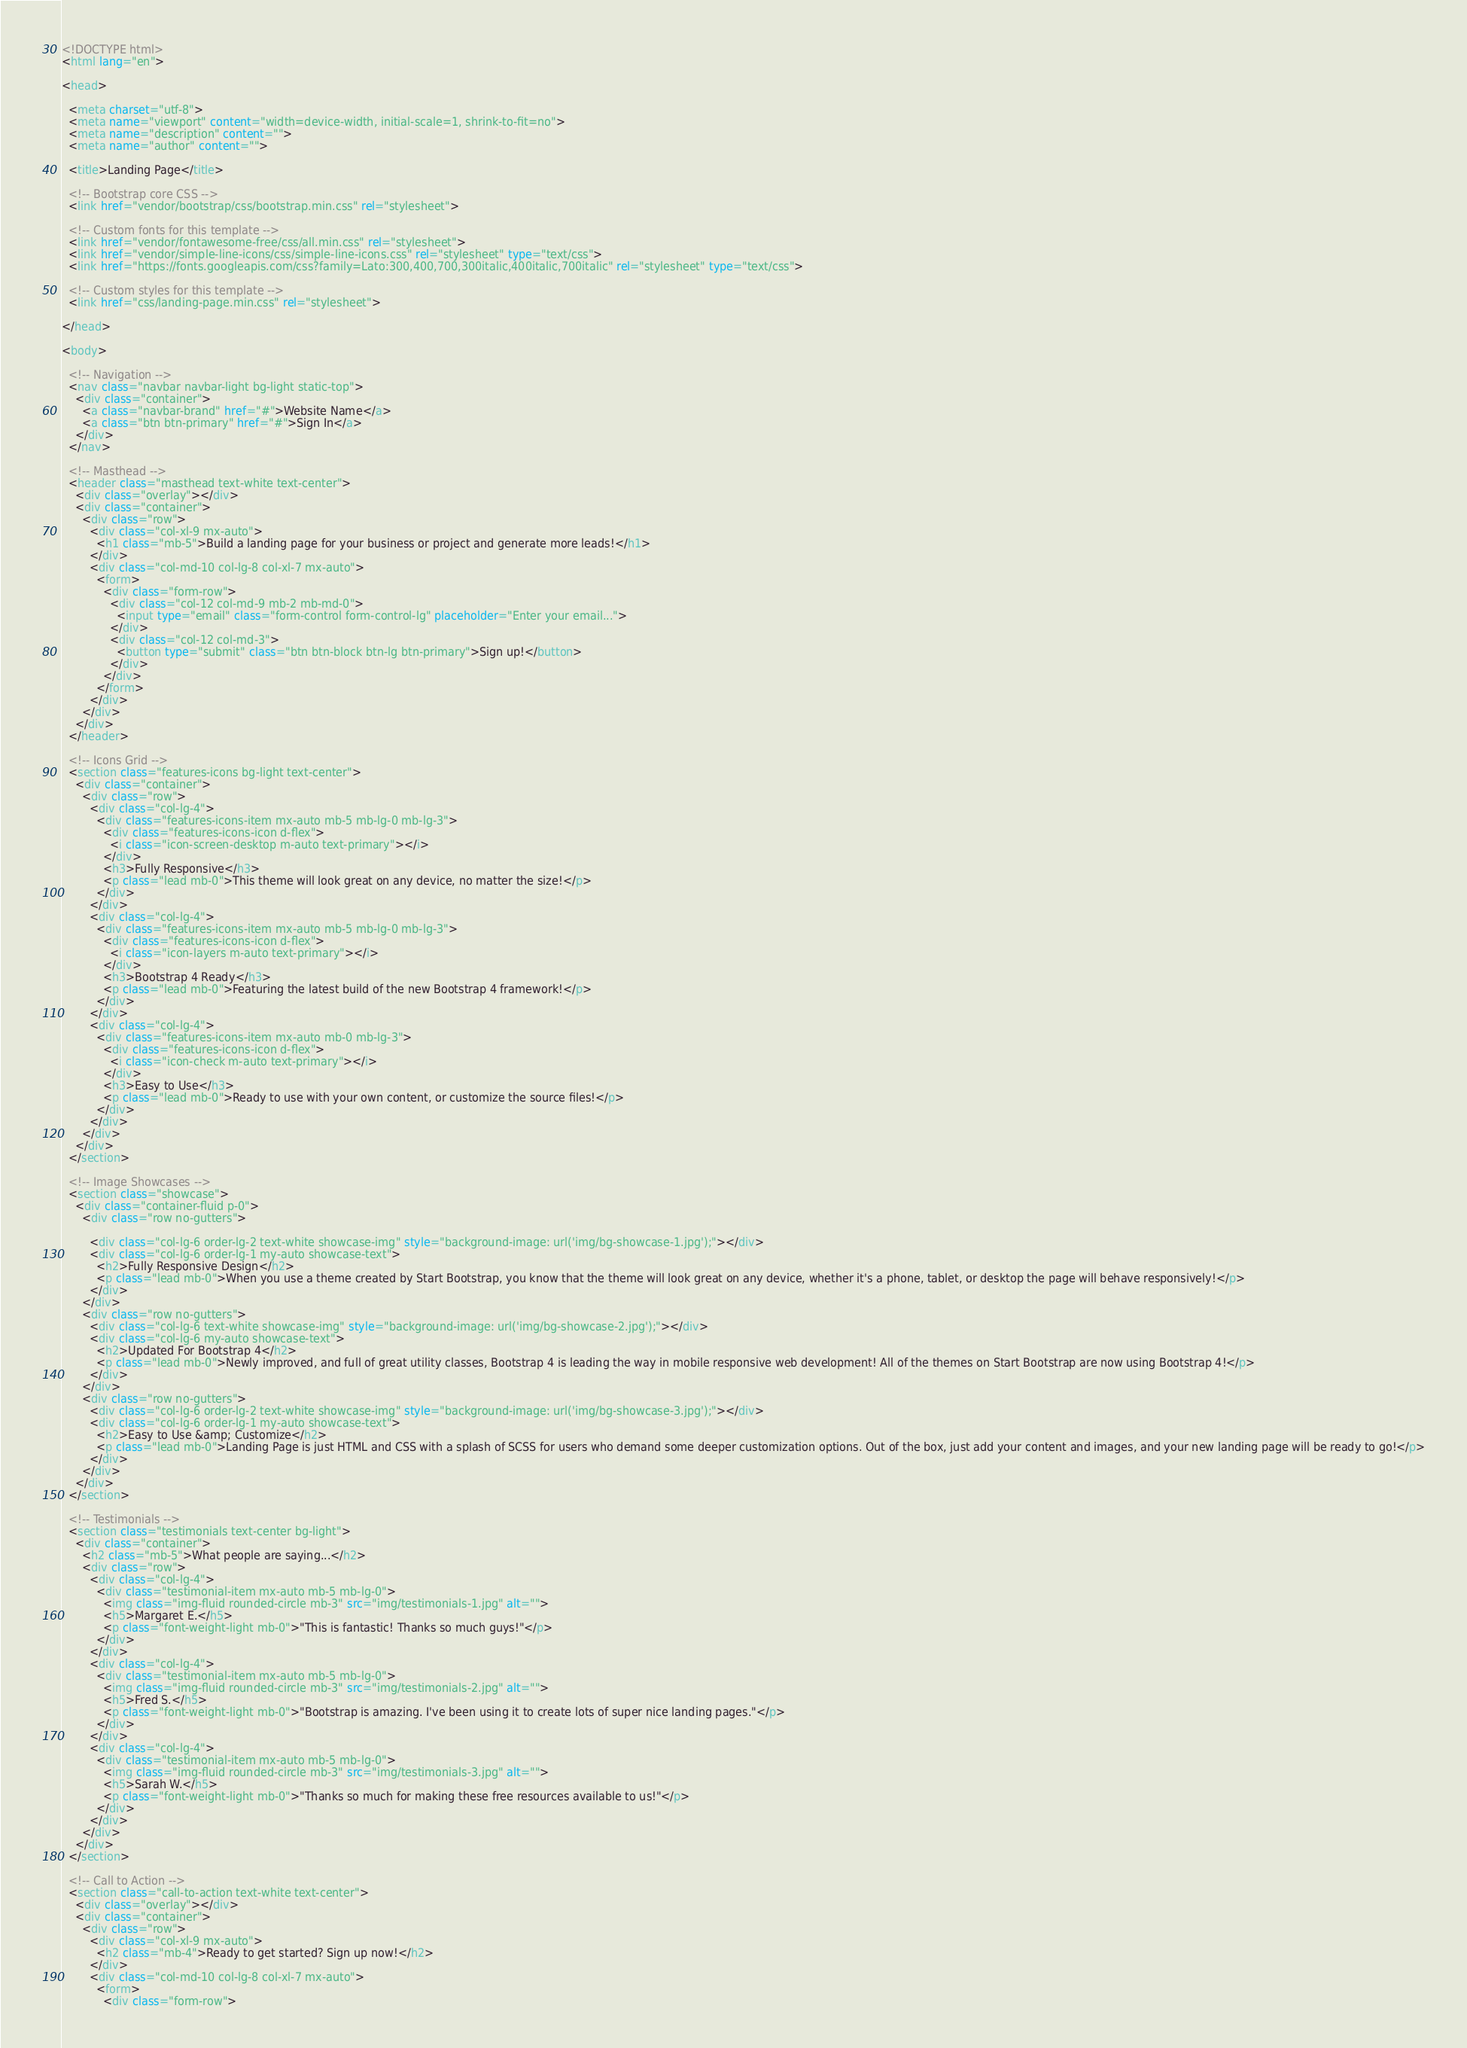<code> <loc_0><loc_0><loc_500><loc_500><_HTML_><!DOCTYPE html>
<html lang="en">

<head>

  <meta charset="utf-8">
  <meta name="viewport" content="width=device-width, initial-scale=1, shrink-to-fit=no">
  <meta name="description" content="">
  <meta name="author" content="">

  <title>Landing Page</title>

  <!-- Bootstrap core CSS -->
  <link href="vendor/bootstrap/css/bootstrap.min.css" rel="stylesheet">

  <!-- Custom fonts for this template -->
  <link href="vendor/fontawesome-free/css/all.min.css" rel="stylesheet">
  <link href="vendor/simple-line-icons/css/simple-line-icons.css" rel="stylesheet" type="text/css">
  <link href="https://fonts.googleapis.com/css?family=Lato:300,400,700,300italic,400italic,700italic" rel="stylesheet" type="text/css">

  <!-- Custom styles for this template -->
  <link href="css/landing-page.min.css" rel="stylesheet">

</head>

<body>

  <!-- Navigation -->
  <nav class="navbar navbar-light bg-light static-top">
    <div class="container">
      <a class="navbar-brand" href="#">Website Name</a>
      <a class="btn btn-primary" href="#">Sign In</a>
    </div>
  </nav>

  <!-- Masthead -->
  <header class="masthead text-white text-center">
    <div class="overlay"></div>
    <div class="container">
      <div class="row">
        <div class="col-xl-9 mx-auto">
          <h1 class="mb-5">Build a landing page for your business or project and generate more leads!</h1>
        </div>
        <div class="col-md-10 col-lg-8 col-xl-7 mx-auto">
          <form>
            <div class="form-row">
              <div class="col-12 col-md-9 mb-2 mb-md-0">
                <input type="email" class="form-control form-control-lg" placeholder="Enter your email...">
              </div>
              <div class="col-12 col-md-3">
                <button type="submit" class="btn btn-block btn-lg btn-primary">Sign up!</button>
              </div>
            </div>
          </form>
        </div>
      </div>
    </div>
  </header>

  <!-- Icons Grid -->
  <section class="features-icons bg-light text-center">
    <div class="container">
      <div class="row">
        <div class="col-lg-4">
          <div class="features-icons-item mx-auto mb-5 mb-lg-0 mb-lg-3">
            <div class="features-icons-icon d-flex">
              <i class="icon-screen-desktop m-auto text-primary"></i>
            </div>
            <h3>Fully Responsive</h3>
            <p class="lead mb-0">This theme will look great on any device, no matter the size!</p>
          </div>
        </div>
        <div class="col-lg-4">
          <div class="features-icons-item mx-auto mb-5 mb-lg-0 mb-lg-3">
            <div class="features-icons-icon d-flex">
              <i class="icon-layers m-auto text-primary"></i>
            </div>
            <h3>Bootstrap 4 Ready</h3>
            <p class="lead mb-0">Featuring the latest build of the new Bootstrap 4 framework!</p>
          </div>
        </div>
        <div class="col-lg-4">
          <div class="features-icons-item mx-auto mb-0 mb-lg-3">
            <div class="features-icons-icon d-flex">
              <i class="icon-check m-auto text-primary"></i>
            </div>
            <h3>Easy to Use</h3>
            <p class="lead mb-0">Ready to use with your own content, or customize the source files!</p>
          </div>
        </div>
      </div>
    </div>
  </section>

  <!-- Image Showcases -->
  <section class="showcase">
    <div class="container-fluid p-0">
      <div class="row no-gutters">

        <div class="col-lg-6 order-lg-2 text-white showcase-img" style="background-image: url('img/bg-showcase-1.jpg');"></div>
        <div class="col-lg-6 order-lg-1 my-auto showcase-text">
          <h2>Fully Responsive Design</h2>
          <p class="lead mb-0">When you use a theme created by Start Bootstrap, you know that the theme will look great on any device, whether it's a phone, tablet, or desktop the page will behave responsively!</p>
        </div>
      </div>
      <div class="row no-gutters">
        <div class="col-lg-6 text-white showcase-img" style="background-image: url('img/bg-showcase-2.jpg');"></div>
        <div class="col-lg-6 my-auto showcase-text">
          <h2>Updated For Bootstrap 4</h2>
          <p class="lead mb-0">Newly improved, and full of great utility classes, Bootstrap 4 is leading the way in mobile responsive web development! All of the themes on Start Bootstrap are now using Bootstrap 4!</p>
        </div>
      </div>
      <div class="row no-gutters">
        <div class="col-lg-6 order-lg-2 text-white showcase-img" style="background-image: url('img/bg-showcase-3.jpg');"></div>
        <div class="col-lg-6 order-lg-1 my-auto showcase-text">
          <h2>Easy to Use &amp; Customize</h2>
          <p class="lead mb-0">Landing Page is just HTML and CSS with a splash of SCSS for users who demand some deeper customization options. Out of the box, just add your content and images, and your new landing page will be ready to go!</p>
        </div>
      </div>
    </div>
  </section>

  <!-- Testimonials -->
  <section class="testimonials text-center bg-light">
    <div class="container">
      <h2 class="mb-5">What people are saying...</h2>
      <div class="row">
        <div class="col-lg-4">
          <div class="testimonial-item mx-auto mb-5 mb-lg-0">
            <img class="img-fluid rounded-circle mb-3" src="img/testimonials-1.jpg" alt="">
            <h5>Margaret E.</h5>
            <p class="font-weight-light mb-0">"This is fantastic! Thanks so much guys!"</p>
          </div>
        </div>
        <div class="col-lg-4">
          <div class="testimonial-item mx-auto mb-5 mb-lg-0">
            <img class="img-fluid rounded-circle mb-3" src="img/testimonials-2.jpg" alt="">
            <h5>Fred S.</h5>
            <p class="font-weight-light mb-0">"Bootstrap is amazing. I've been using it to create lots of super nice landing pages."</p>
          </div>
        </div>
        <div class="col-lg-4">
          <div class="testimonial-item mx-auto mb-5 mb-lg-0">
            <img class="img-fluid rounded-circle mb-3" src="img/testimonials-3.jpg" alt="">
            <h5>Sarah W.</h5>
            <p class="font-weight-light mb-0">"Thanks so much for making these free resources available to us!"</p>
          </div>
        </div>
      </div>
    </div>
  </section>

  <!-- Call to Action -->
  <section class="call-to-action text-white text-center">
    <div class="overlay"></div>
    <div class="container">
      <div class="row">
        <div class="col-xl-9 mx-auto">
          <h2 class="mb-4">Ready to get started? Sign up now!</h2>
        </div>
        <div class="col-md-10 col-lg-8 col-xl-7 mx-auto">
          <form>
            <div class="form-row"></code> 